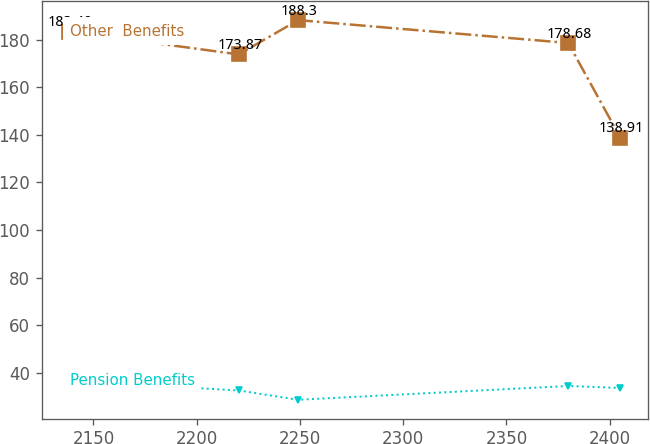Convert chart. <chart><loc_0><loc_0><loc_500><loc_500><line_chart><ecel><fcel>Other  Benefits<fcel>Pension Benefits<nl><fcel>2138.23<fcel>183.49<fcel>36.59<nl><fcel>2220.36<fcel>173.87<fcel>32.49<nl><fcel>2249.13<fcel>188.3<fcel>28.58<nl><fcel>2379.92<fcel>178.68<fcel>34.38<nl><fcel>2405.12<fcel>138.91<fcel>33.55<nl></chart> 